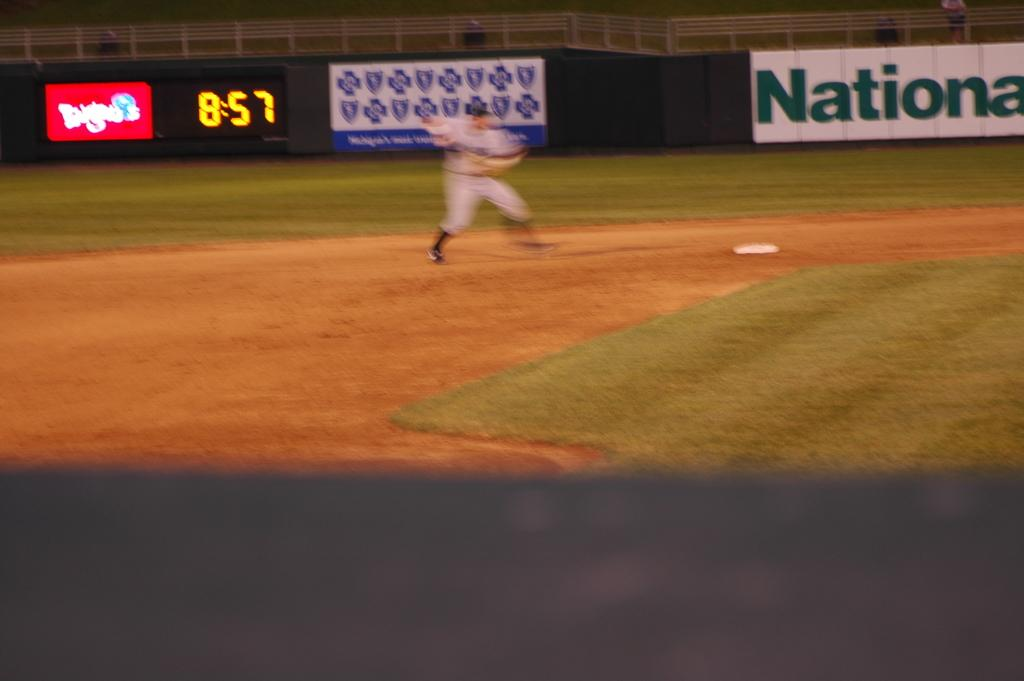Provide a one-sentence caption for the provided image. The clock behind the baseball player indicates it is 8:57. 